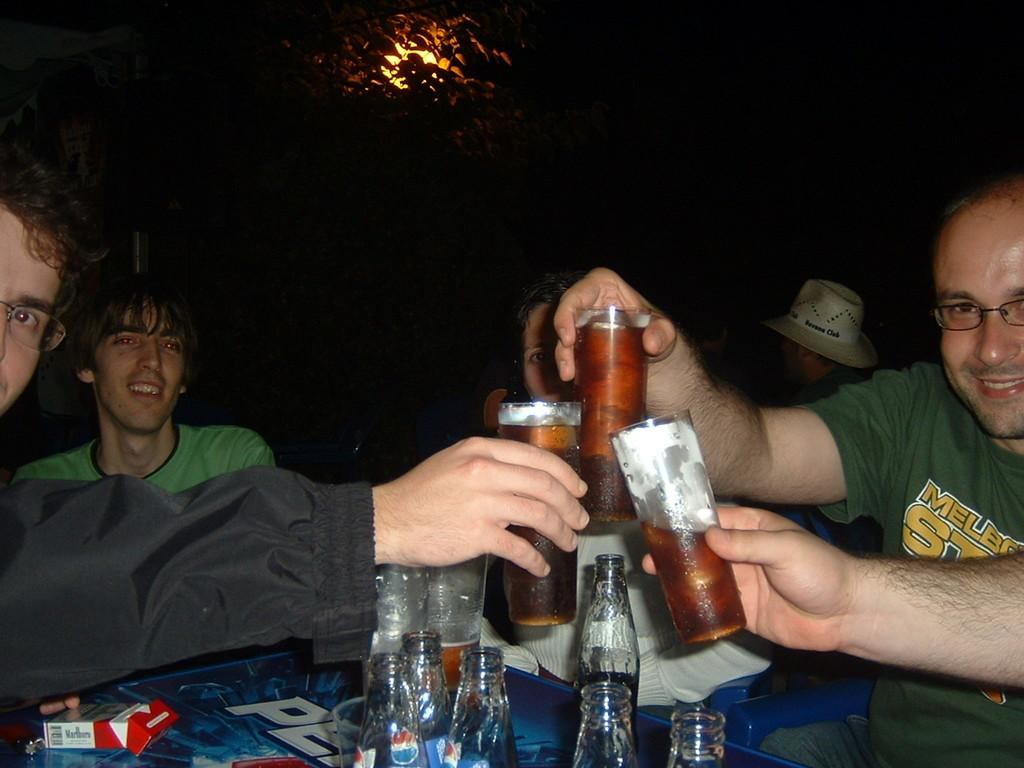<image>
Give a short and clear explanation of the subsequent image. A pack of Marlboros is visible on top of the table. 